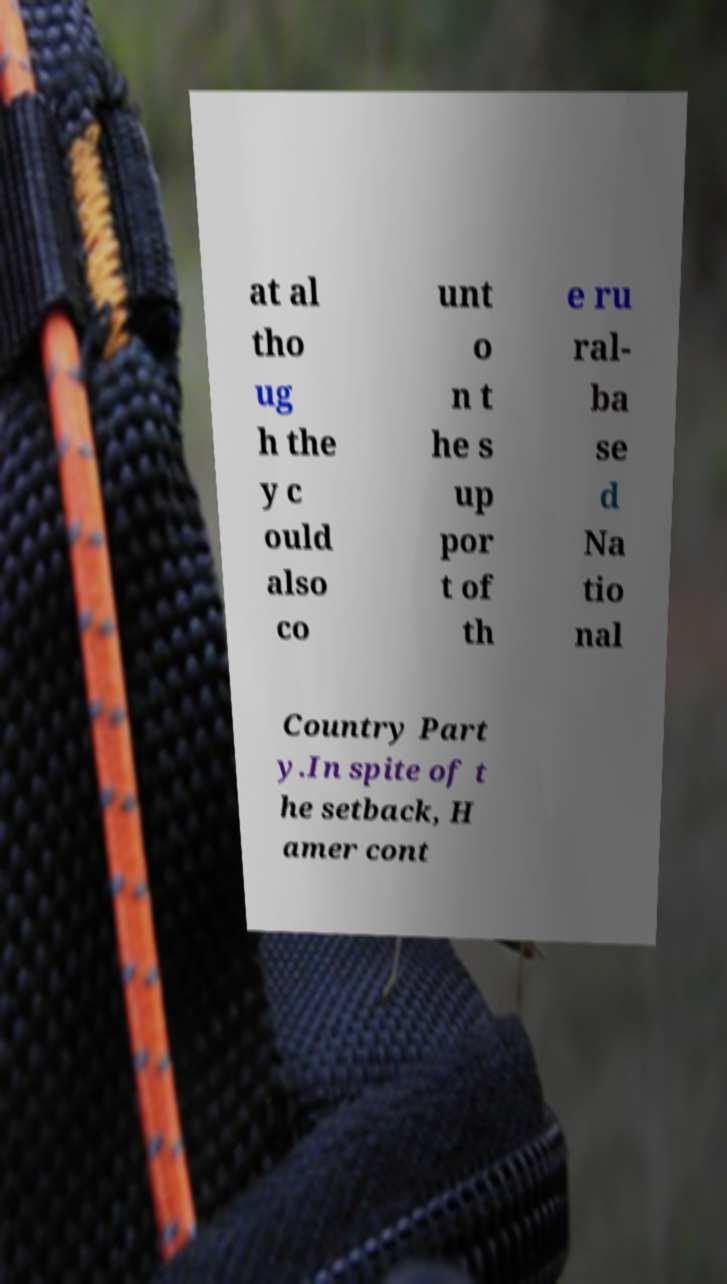Could you extract and type out the text from this image? at al tho ug h the y c ould also co unt o n t he s up por t of th e ru ral- ba se d Na tio nal Country Part y.In spite of t he setback, H amer cont 